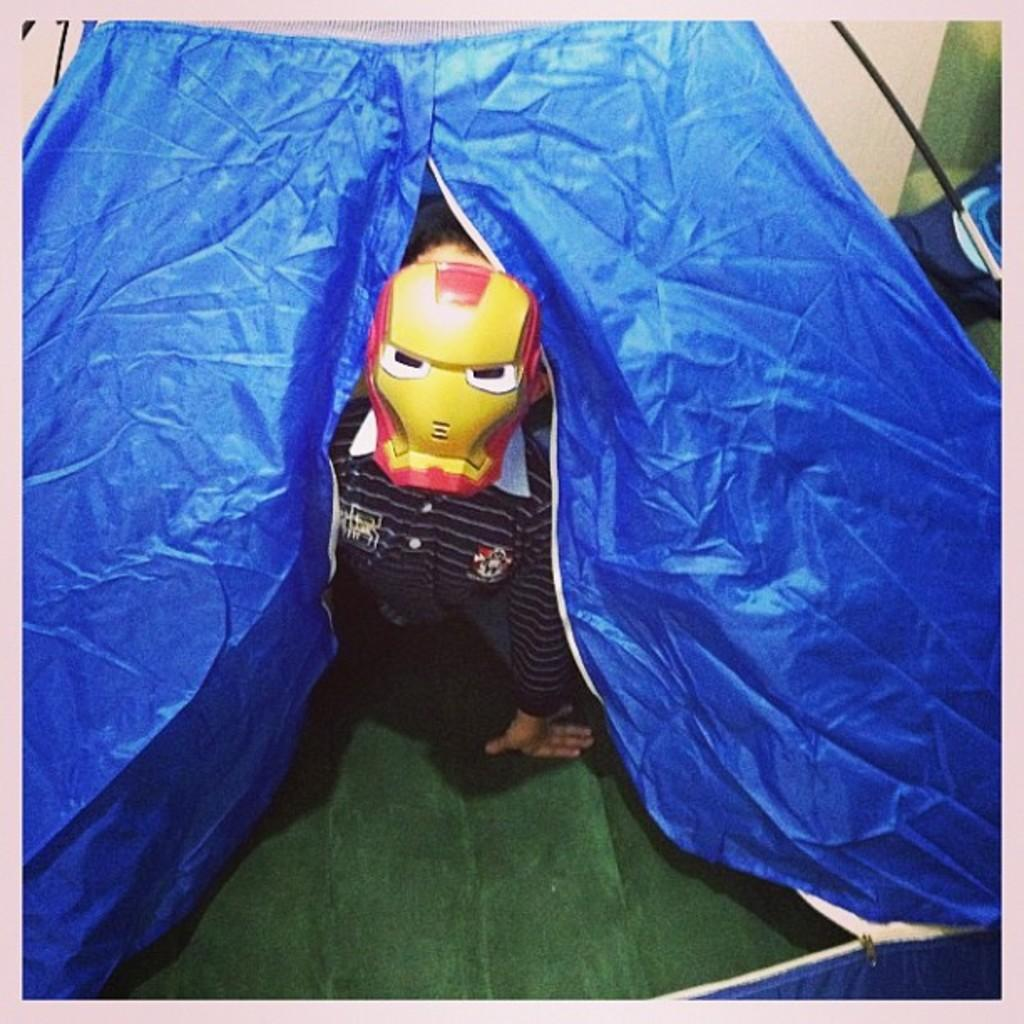What is the main subject of the image? The main subject of the image is a kid. What is the kid wearing in the image? The kid is wearing a face mask in the image. What structure can be seen in the image? There is a tent in the image. What objects are present in the top right corner of the image? There are objects present in the top right corner of the image, but their specific nature is not mentioned in the facts. What type of sail is visible in the image? There is no sail present in the image. What is the name of the stove used by the kid in the image? There is no stove present in the image, so it is not possible to determine its name. 